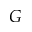<formula> <loc_0><loc_0><loc_500><loc_500>G</formula> 